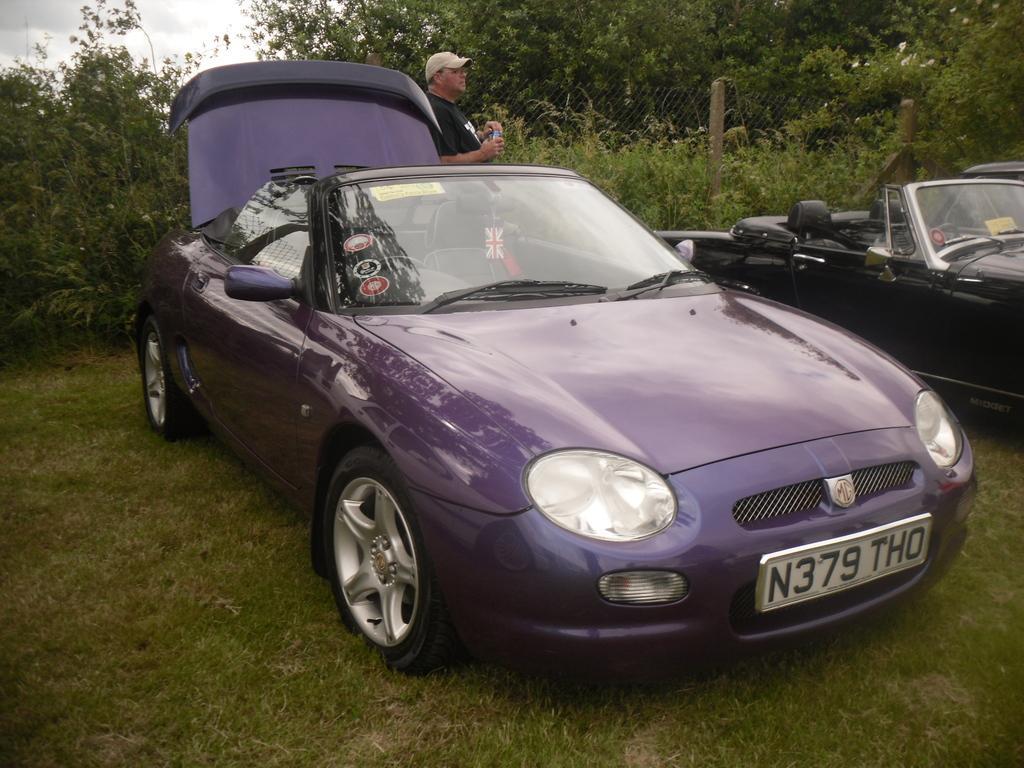Describe this image in one or two sentences. In the foreground of the picture there are cars, grass and a person. In the center of the picture there are plants, trees and fencing. In the background it is sky, sky is cloudy. 